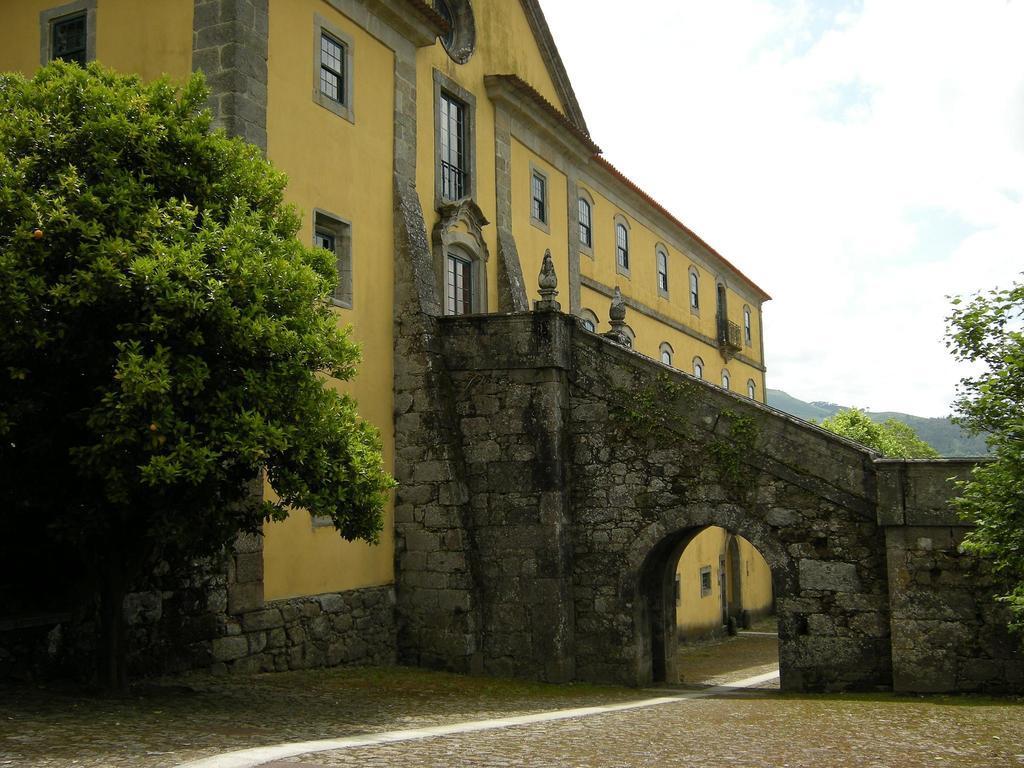Could you give a brief overview of what you see in this image? In this image I can see a building. On the right side there is a wall. At the bottom we can see the ground. On the right and left side of the image there are trees. At the top of the image I can see the sky and clouds. 